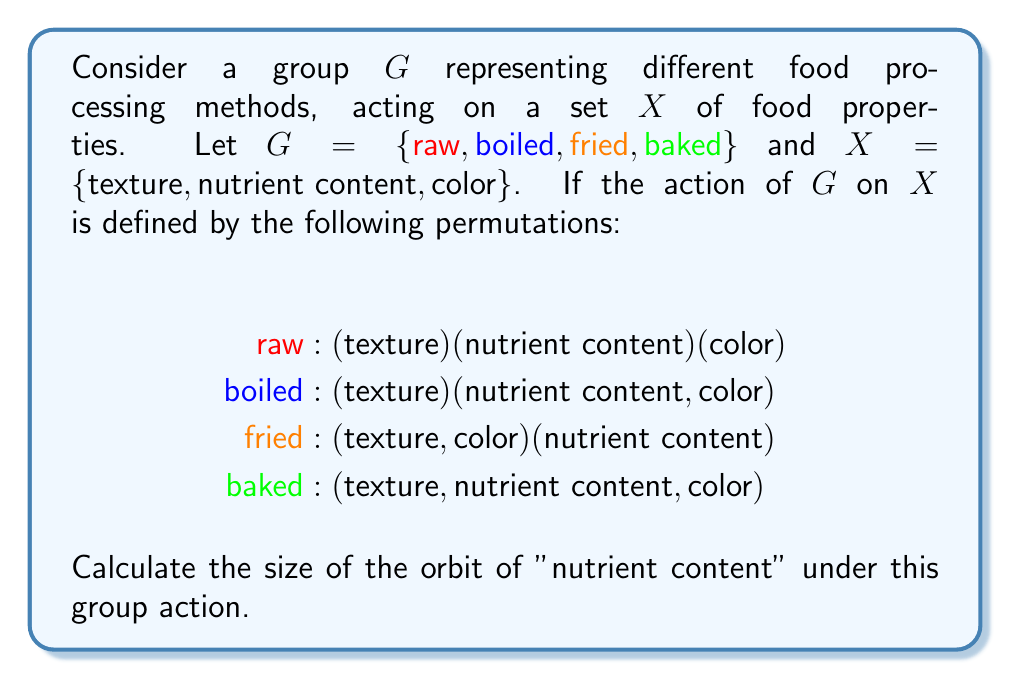What is the answer to this math problem? To find the size of the orbit of "nutrient content", we need to follow these steps:

1) Recall that the orbit of an element $x \in X$ under a group action is defined as:
   $\text{Orb}(x) = \{g \cdot x : g \in G\}$

2) In this case, we need to find $\text{Orb}(\text{nutrient content})$.

3) Let's apply each element of $G$ to "nutrient content":

   - $\text{raw} \cdot \text{nutrient content} = \text{nutrient content}$
   - $\text{boiled} \cdot \text{nutrient content} = \text{color}$
   - $\text{fried} \cdot \text{nutrient content} = \text{nutrient content}$
   - $\text{baked} \cdot \text{nutrient content} = \text{color}$

4) From this, we can see that the orbit of "nutrient content" contains two elements:
   $\text{Orb}(\text{nutrient content}) = \{\text{nutrient content}, \text{color}\}$

5) Therefore, the size of the orbit is 2.

This result indicates that the processing methods in this group can alter the nutrient content to affect either itself or the color of the food, which is relevant to a food scientist studying the effects of processing on nutritional composition.
Answer: 2 